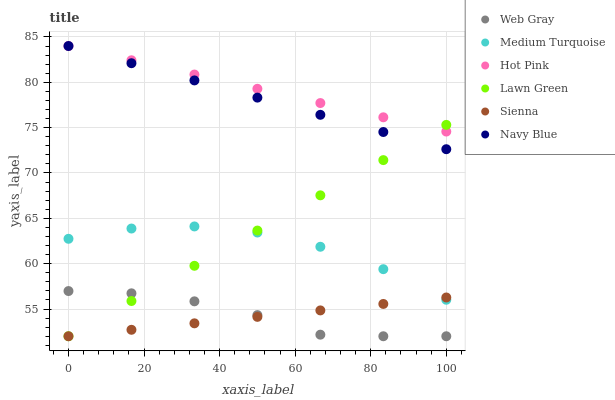Does Sienna have the minimum area under the curve?
Answer yes or no. Yes. Does Hot Pink have the maximum area under the curve?
Answer yes or no. Yes. Does Web Gray have the minimum area under the curve?
Answer yes or no. No. Does Web Gray have the maximum area under the curve?
Answer yes or no. No. Is Hot Pink the smoothest?
Answer yes or no. Yes. Is Medium Turquoise the roughest?
Answer yes or no. Yes. Is Web Gray the smoothest?
Answer yes or no. No. Is Web Gray the roughest?
Answer yes or no. No. Does Lawn Green have the lowest value?
Answer yes or no. Yes. Does Navy Blue have the lowest value?
Answer yes or no. No. Does Hot Pink have the highest value?
Answer yes or no. Yes. Does Web Gray have the highest value?
Answer yes or no. No. Is Medium Turquoise less than Hot Pink?
Answer yes or no. Yes. Is Hot Pink greater than Medium Turquoise?
Answer yes or no. Yes. Does Navy Blue intersect Lawn Green?
Answer yes or no. Yes. Is Navy Blue less than Lawn Green?
Answer yes or no. No. Is Navy Blue greater than Lawn Green?
Answer yes or no. No. Does Medium Turquoise intersect Hot Pink?
Answer yes or no. No. 